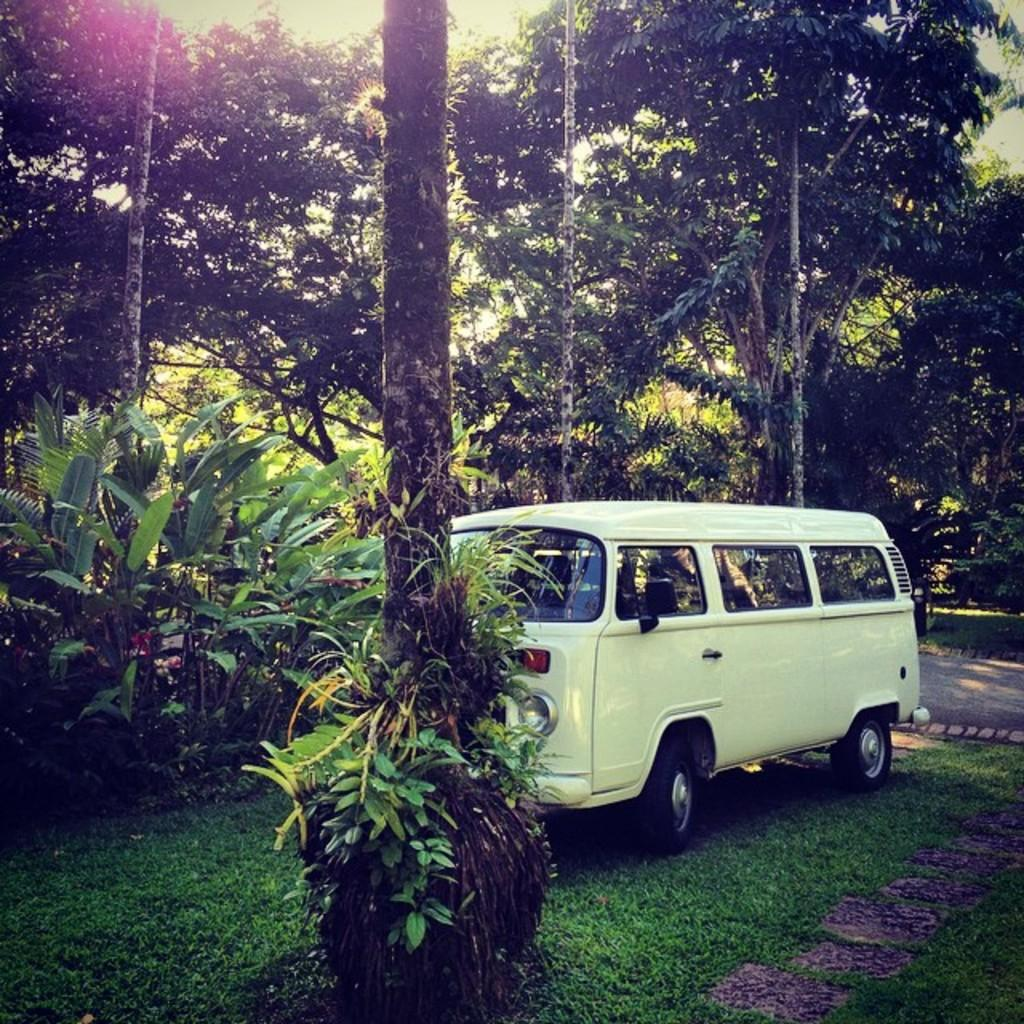What type of vegetation can be seen in the image? There are trees in the image. What type of vehicle is present in the image? There is a white-colored van in the image. What is the ground covered with in the image? There is grass visible in the image. What type of wax is being used to create the design on the van? There is no mention of wax or a design on the van in the provided facts, so we cannot answer this question. 